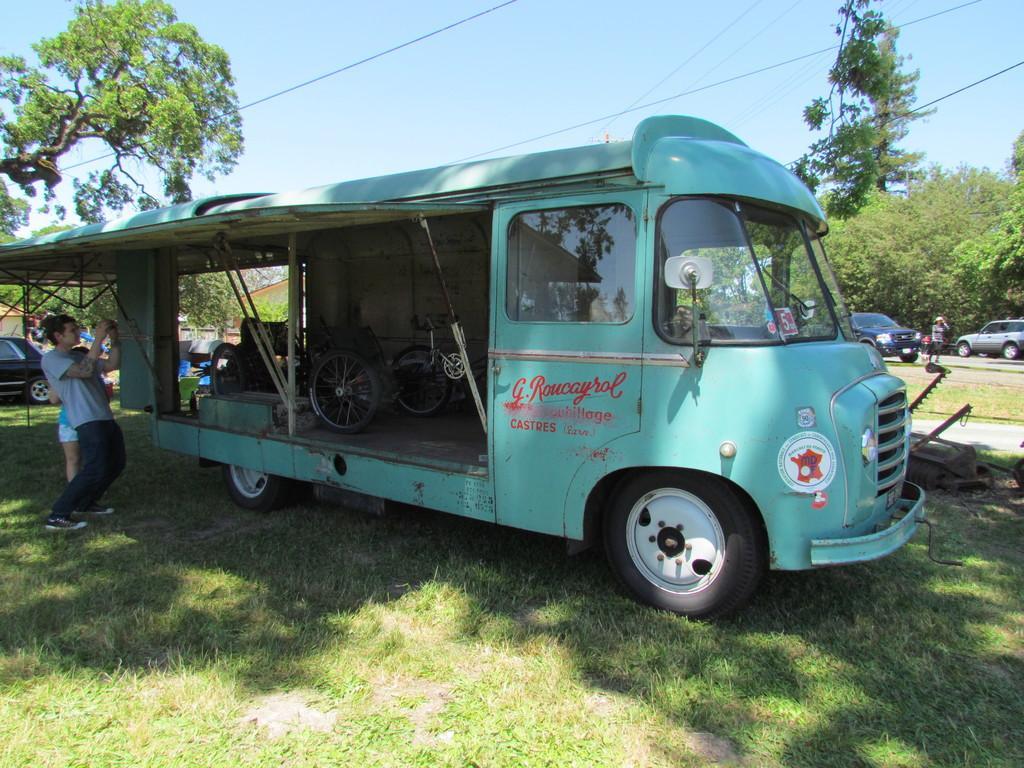Please provide a concise description of this image. In the image there is a vehicle and there are two people standing under the roof of that vehicle, there are many cars parked around the vehicle on the ground and in the background there are many trees. 